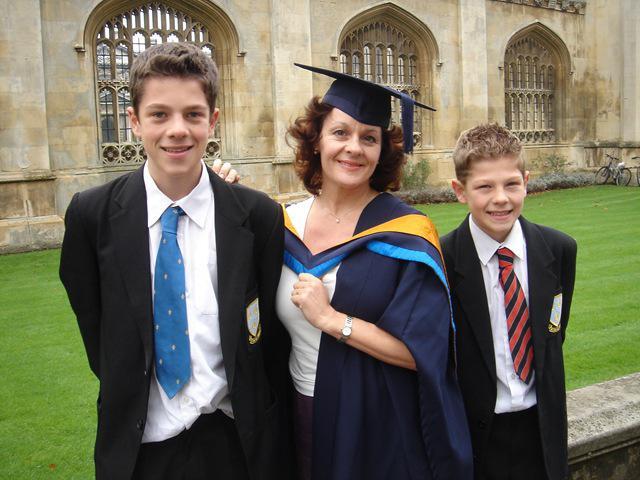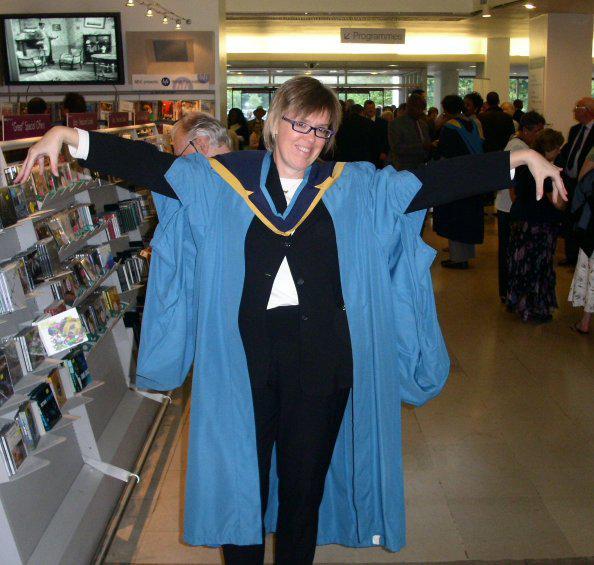The first image is the image on the left, the second image is the image on the right. For the images shown, is this caption "A smiling woman with short hair is seen from the front wearing a sky blue gown, open to show her clothing, with dark navy blue and yellow at her neck." true? Answer yes or no. Yes. The first image is the image on the left, the second image is the image on the right. For the images shown, is this caption "One of the images shows a man wearing a blue and yellow stole holding a rolled up diploma in his hands that is tied with a red ribbon." true? Answer yes or no. No. 